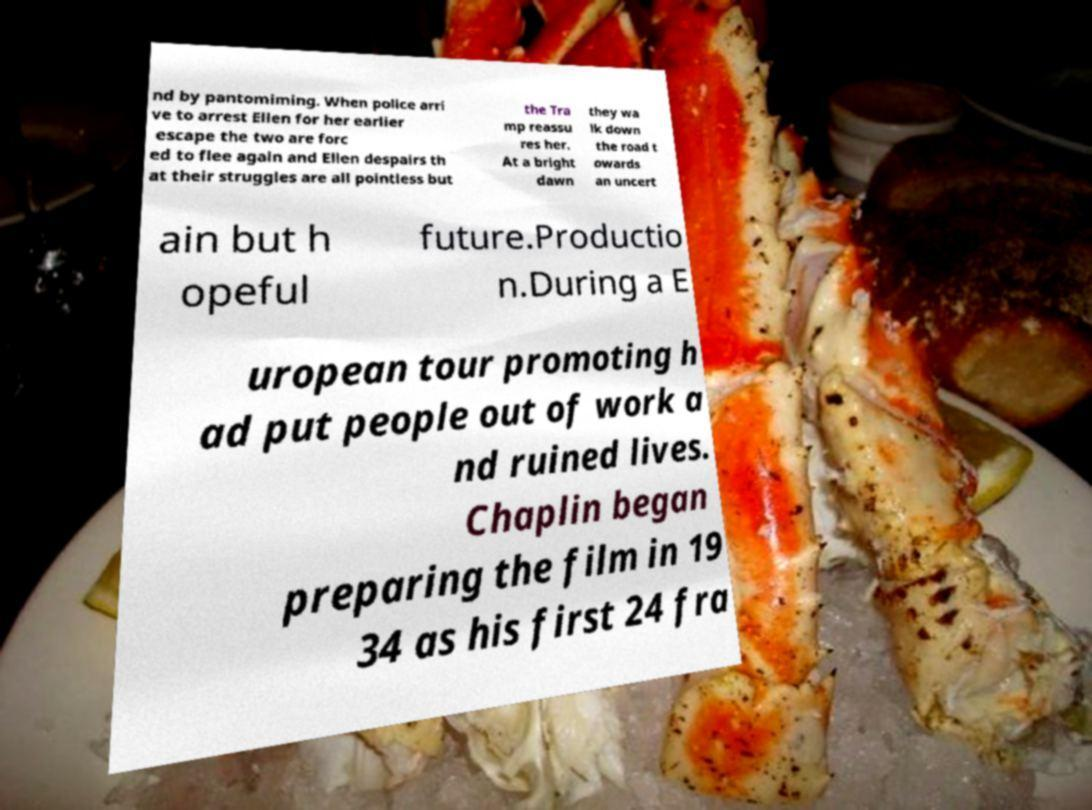Please identify and transcribe the text found in this image. nd by pantomiming. When police arri ve to arrest Ellen for her earlier escape the two are forc ed to flee again and Ellen despairs th at their struggles are all pointless but the Tra mp reassu res her. At a bright dawn they wa lk down the road t owards an uncert ain but h opeful future.Productio n.During a E uropean tour promoting h ad put people out of work a nd ruined lives. Chaplin began preparing the film in 19 34 as his first 24 fra 